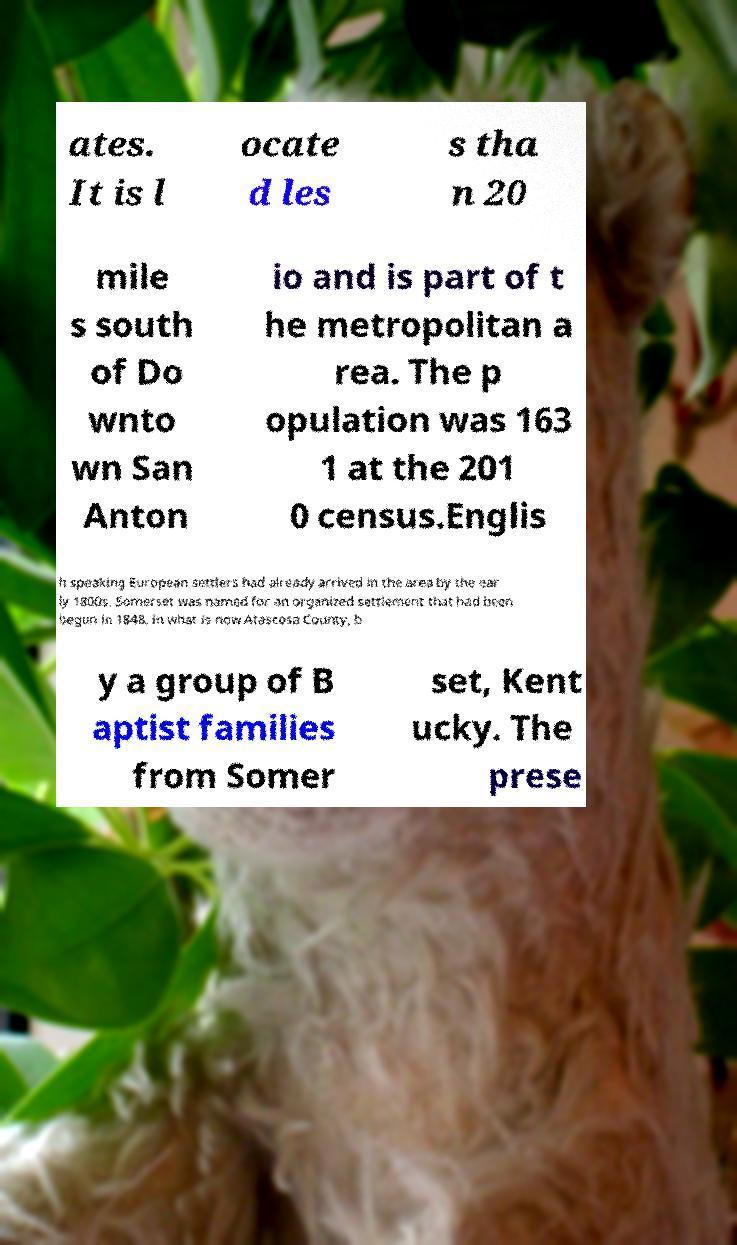Can you accurately transcribe the text from the provided image for me? ates. It is l ocate d les s tha n 20 mile s south of Do wnto wn San Anton io and is part of t he metropolitan a rea. The p opulation was 163 1 at the 201 0 census.Englis h speaking European settlers had already arrived in the area by the ear ly 1800s. Somerset was named for an organized settlement that had been begun in 1848, in what is now Atascosa County, b y a group of B aptist families from Somer set, Kent ucky. The prese 